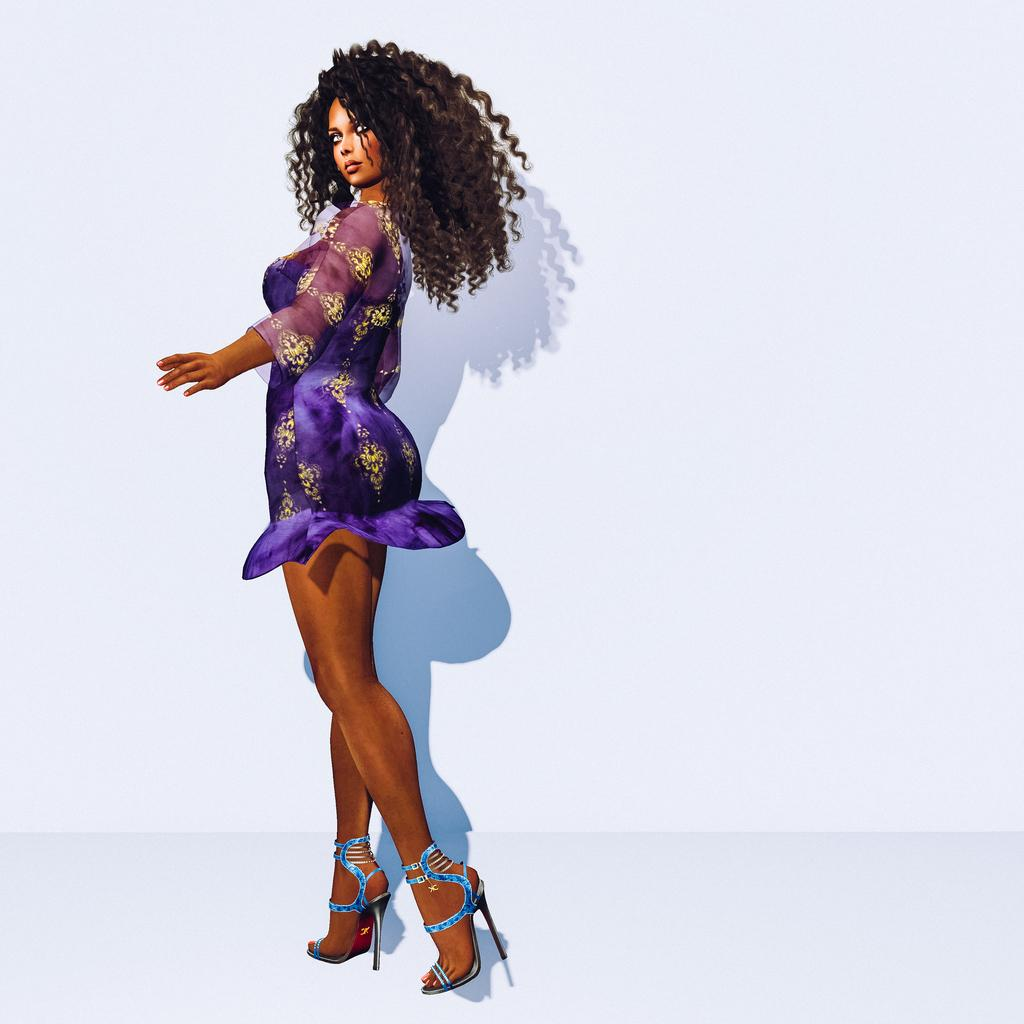What is the main subject of the image? The main subject of the image is an animation of a woman. What month is depicted in the animation of the woman? There is no specific month depicted in the animation of the woman, as the image only shows an animation of a woman without any reference to a particular month. 